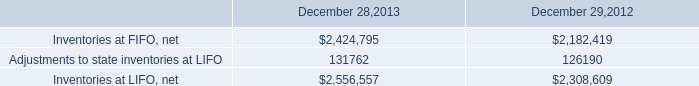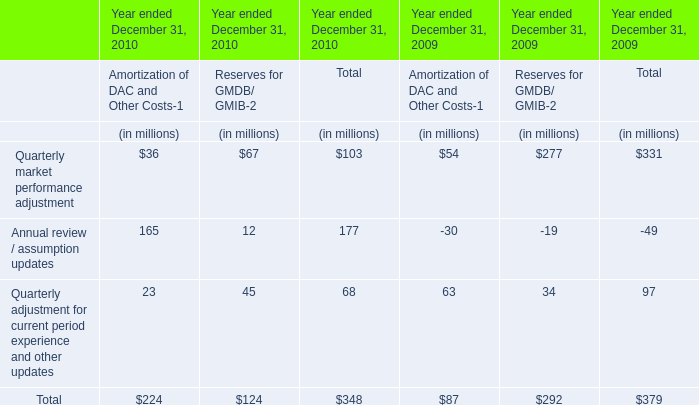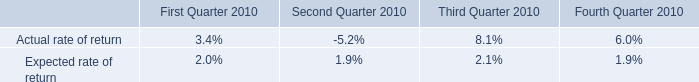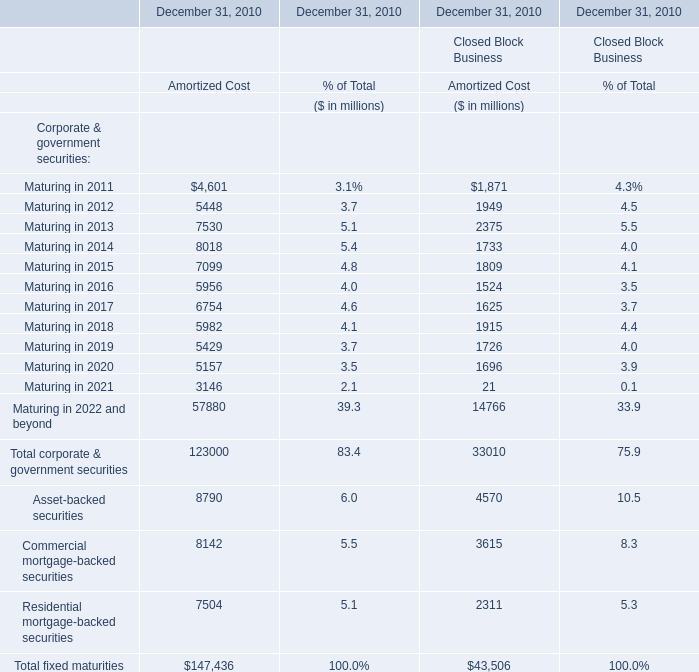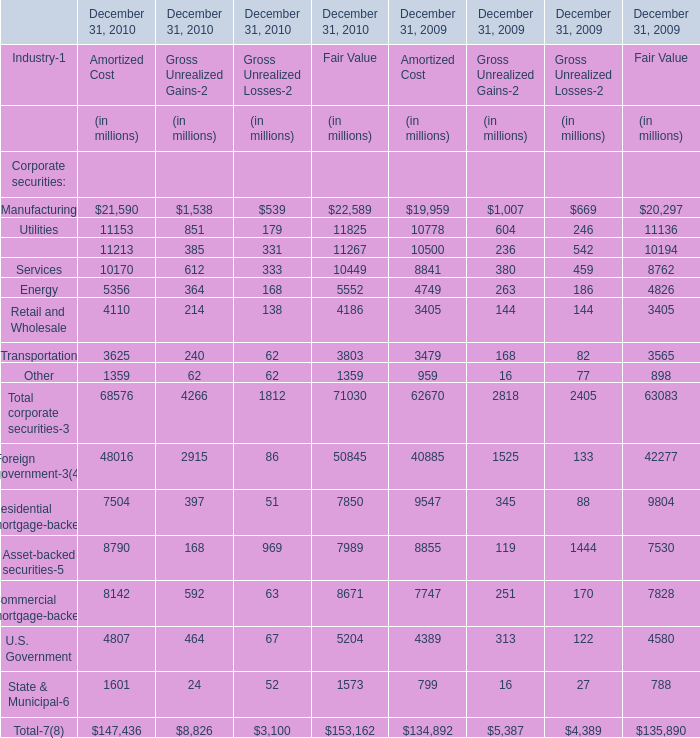How many kinds of Amortized Cost are greater than 50000 in 2010 for Financial Services Businesses? 
Answer: 3. 